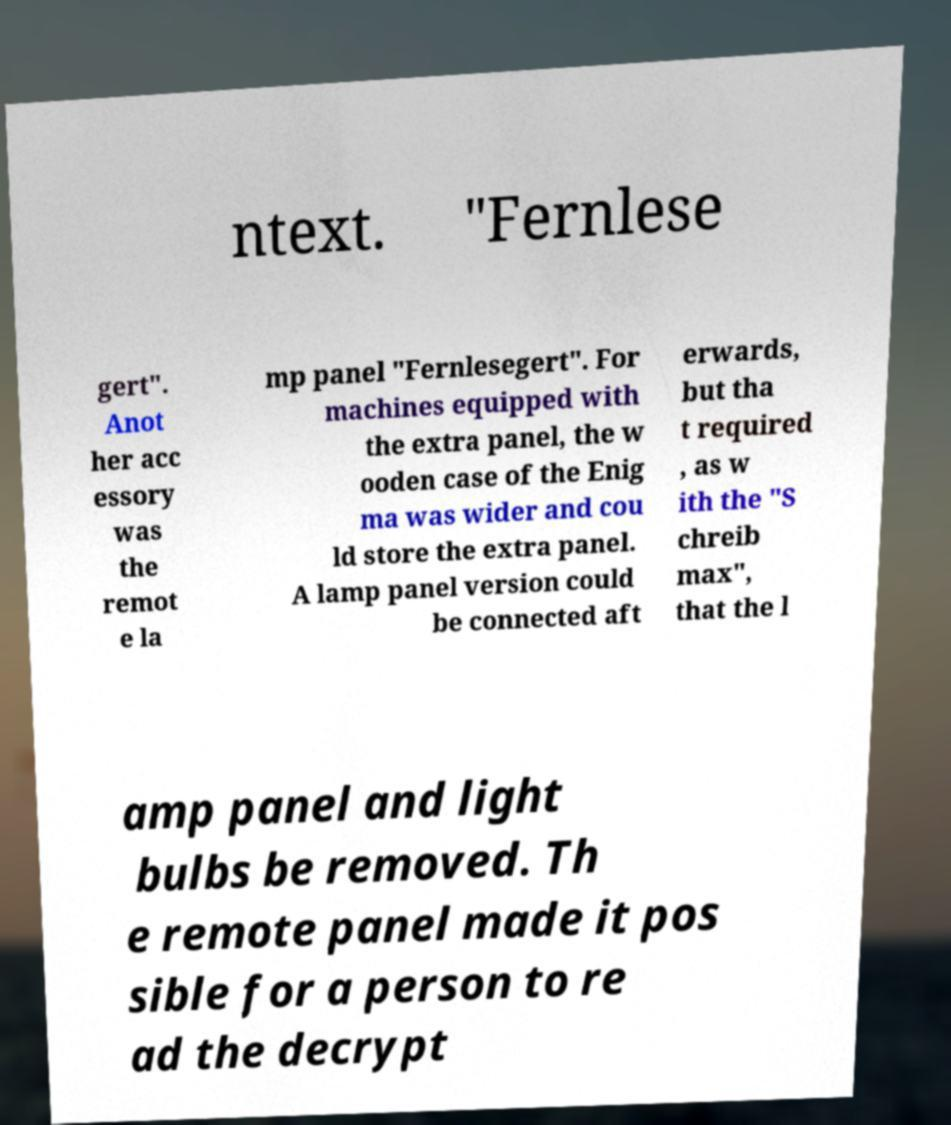What messages or text are displayed in this image? I need them in a readable, typed format. ntext. "Fernlese gert". Anot her acc essory was the remot e la mp panel "Fernlesegert". For machines equipped with the extra panel, the w ooden case of the Enig ma was wider and cou ld store the extra panel. A lamp panel version could be connected aft erwards, but tha t required , as w ith the "S chreib max", that the l amp panel and light bulbs be removed. Th e remote panel made it pos sible for a person to re ad the decrypt 